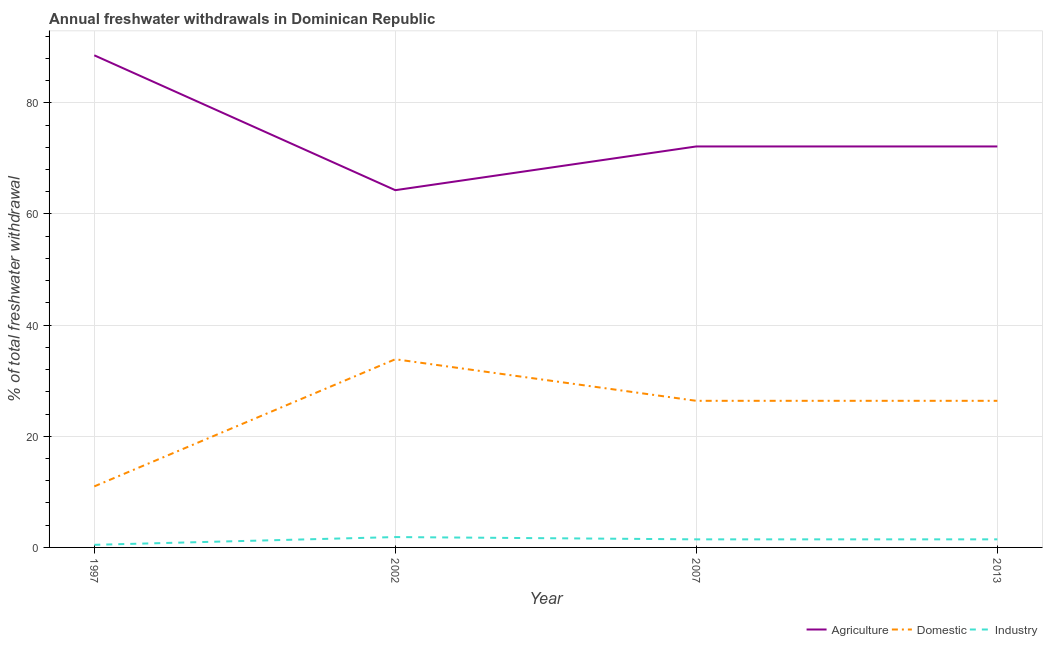How many different coloured lines are there?
Offer a very short reply. 3. Is the number of lines equal to the number of legend labels?
Give a very brief answer. Yes. What is the percentage of freshwater withdrawal for agriculture in 1997?
Your answer should be compact. 88.55. Across all years, what is the maximum percentage of freshwater withdrawal for industry?
Make the answer very short. 1.86. Across all years, what is the minimum percentage of freshwater withdrawal for industry?
Provide a short and direct response. 0.47. What is the total percentage of freshwater withdrawal for agriculture in the graph?
Offer a terse response. 297.13. What is the difference between the percentage of freshwater withdrawal for industry in 1997 and that in 2002?
Provide a short and direct response. -1.4. What is the difference between the percentage of freshwater withdrawal for industry in 1997 and the percentage of freshwater withdrawal for agriculture in 2002?
Provide a short and direct response. -63.81. What is the average percentage of freshwater withdrawal for domestic purposes per year?
Give a very brief answer. 24.4. In the year 2002, what is the difference between the percentage of freshwater withdrawal for industry and percentage of freshwater withdrawal for domestic purposes?
Make the answer very short. -32. What is the ratio of the percentage of freshwater withdrawal for industry in 1997 to that in 2007?
Offer a terse response. 0.32. Is the difference between the percentage of freshwater withdrawal for industry in 1997 and 2007 greater than the difference between the percentage of freshwater withdrawal for domestic purposes in 1997 and 2007?
Provide a succinct answer. Yes. What is the difference between the highest and the second highest percentage of freshwater withdrawal for industry?
Provide a succinct answer. 0.41. What is the difference between the highest and the lowest percentage of freshwater withdrawal for domestic purposes?
Your response must be concise. 22.88. Is it the case that in every year, the sum of the percentage of freshwater withdrawal for agriculture and percentage of freshwater withdrawal for domestic purposes is greater than the percentage of freshwater withdrawal for industry?
Give a very brief answer. Yes. Is the percentage of freshwater withdrawal for domestic purposes strictly less than the percentage of freshwater withdrawal for industry over the years?
Make the answer very short. No. How many lines are there?
Your answer should be compact. 3. How many years are there in the graph?
Your response must be concise. 4. Does the graph contain grids?
Provide a short and direct response. Yes. How many legend labels are there?
Give a very brief answer. 3. What is the title of the graph?
Your response must be concise. Annual freshwater withdrawals in Dominican Republic. What is the label or title of the Y-axis?
Your answer should be compact. % of total freshwater withdrawal. What is the % of total freshwater withdrawal of Agriculture in 1997?
Your answer should be compact. 88.55. What is the % of total freshwater withdrawal in Domestic in 1997?
Your answer should be very brief. 10.98. What is the % of total freshwater withdrawal of Industry in 1997?
Your answer should be compact. 0.47. What is the % of total freshwater withdrawal in Agriculture in 2002?
Provide a succinct answer. 64.28. What is the % of total freshwater withdrawal in Domestic in 2002?
Provide a short and direct response. 33.86. What is the % of total freshwater withdrawal in Industry in 2002?
Give a very brief answer. 1.86. What is the % of total freshwater withdrawal of Agriculture in 2007?
Offer a terse response. 72.15. What is the % of total freshwater withdrawal of Domestic in 2007?
Offer a terse response. 26.38. What is the % of total freshwater withdrawal of Industry in 2007?
Ensure brevity in your answer.  1.45. What is the % of total freshwater withdrawal in Agriculture in 2013?
Keep it short and to the point. 72.15. What is the % of total freshwater withdrawal of Domestic in 2013?
Offer a terse response. 26.38. What is the % of total freshwater withdrawal in Industry in 2013?
Provide a succinct answer. 1.45. Across all years, what is the maximum % of total freshwater withdrawal in Agriculture?
Ensure brevity in your answer.  88.55. Across all years, what is the maximum % of total freshwater withdrawal in Domestic?
Your answer should be very brief. 33.86. Across all years, what is the maximum % of total freshwater withdrawal of Industry?
Provide a short and direct response. 1.86. Across all years, what is the minimum % of total freshwater withdrawal of Agriculture?
Your answer should be compact. 64.28. Across all years, what is the minimum % of total freshwater withdrawal of Domestic?
Offer a very short reply. 10.98. Across all years, what is the minimum % of total freshwater withdrawal in Industry?
Offer a very short reply. 0.47. What is the total % of total freshwater withdrawal in Agriculture in the graph?
Your response must be concise. 297.13. What is the total % of total freshwater withdrawal of Domestic in the graph?
Your answer should be compact. 97.6. What is the total % of total freshwater withdrawal of Industry in the graph?
Offer a terse response. 5.24. What is the difference between the % of total freshwater withdrawal of Agriculture in 1997 and that in 2002?
Ensure brevity in your answer.  24.27. What is the difference between the % of total freshwater withdrawal in Domestic in 1997 and that in 2002?
Your response must be concise. -22.88. What is the difference between the % of total freshwater withdrawal in Industry in 1997 and that in 2002?
Provide a succinct answer. -1.4. What is the difference between the % of total freshwater withdrawal of Domestic in 1997 and that in 2007?
Your answer should be very brief. -15.4. What is the difference between the % of total freshwater withdrawal of Industry in 1997 and that in 2007?
Ensure brevity in your answer.  -0.99. What is the difference between the % of total freshwater withdrawal of Agriculture in 1997 and that in 2013?
Your answer should be compact. 16.4. What is the difference between the % of total freshwater withdrawal in Domestic in 1997 and that in 2013?
Give a very brief answer. -15.4. What is the difference between the % of total freshwater withdrawal in Industry in 1997 and that in 2013?
Keep it short and to the point. -0.99. What is the difference between the % of total freshwater withdrawal in Agriculture in 2002 and that in 2007?
Your answer should be very brief. -7.87. What is the difference between the % of total freshwater withdrawal in Domestic in 2002 and that in 2007?
Provide a short and direct response. 7.48. What is the difference between the % of total freshwater withdrawal of Industry in 2002 and that in 2007?
Make the answer very short. 0.41. What is the difference between the % of total freshwater withdrawal of Agriculture in 2002 and that in 2013?
Ensure brevity in your answer.  -7.87. What is the difference between the % of total freshwater withdrawal of Domestic in 2002 and that in 2013?
Your answer should be very brief. 7.48. What is the difference between the % of total freshwater withdrawal in Industry in 2002 and that in 2013?
Give a very brief answer. 0.41. What is the difference between the % of total freshwater withdrawal in Agriculture in 1997 and the % of total freshwater withdrawal in Domestic in 2002?
Provide a succinct answer. 54.69. What is the difference between the % of total freshwater withdrawal of Agriculture in 1997 and the % of total freshwater withdrawal of Industry in 2002?
Your response must be concise. 86.69. What is the difference between the % of total freshwater withdrawal of Domestic in 1997 and the % of total freshwater withdrawal of Industry in 2002?
Offer a terse response. 9.12. What is the difference between the % of total freshwater withdrawal of Agriculture in 1997 and the % of total freshwater withdrawal of Domestic in 2007?
Give a very brief answer. 62.17. What is the difference between the % of total freshwater withdrawal in Agriculture in 1997 and the % of total freshwater withdrawal in Industry in 2007?
Provide a succinct answer. 87.1. What is the difference between the % of total freshwater withdrawal in Domestic in 1997 and the % of total freshwater withdrawal in Industry in 2007?
Offer a terse response. 9.53. What is the difference between the % of total freshwater withdrawal in Agriculture in 1997 and the % of total freshwater withdrawal in Domestic in 2013?
Ensure brevity in your answer.  62.17. What is the difference between the % of total freshwater withdrawal of Agriculture in 1997 and the % of total freshwater withdrawal of Industry in 2013?
Provide a short and direct response. 87.1. What is the difference between the % of total freshwater withdrawal of Domestic in 1997 and the % of total freshwater withdrawal of Industry in 2013?
Your answer should be very brief. 9.53. What is the difference between the % of total freshwater withdrawal of Agriculture in 2002 and the % of total freshwater withdrawal of Domestic in 2007?
Provide a succinct answer. 37.9. What is the difference between the % of total freshwater withdrawal of Agriculture in 2002 and the % of total freshwater withdrawal of Industry in 2007?
Provide a succinct answer. 62.83. What is the difference between the % of total freshwater withdrawal of Domestic in 2002 and the % of total freshwater withdrawal of Industry in 2007?
Provide a succinct answer. 32.41. What is the difference between the % of total freshwater withdrawal of Agriculture in 2002 and the % of total freshwater withdrawal of Domestic in 2013?
Your answer should be compact. 37.9. What is the difference between the % of total freshwater withdrawal of Agriculture in 2002 and the % of total freshwater withdrawal of Industry in 2013?
Give a very brief answer. 62.83. What is the difference between the % of total freshwater withdrawal in Domestic in 2002 and the % of total freshwater withdrawal in Industry in 2013?
Give a very brief answer. 32.41. What is the difference between the % of total freshwater withdrawal in Agriculture in 2007 and the % of total freshwater withdrawal in Domestic in 2013?
Your answer should be compact. 45.77. What is the difference between the % of total freshwater withdrawal in Agriculture in 2007 and the % of total freshwater withdrawal in Industry in 2013?
Provide a short and direct response. 70.7. What is the difference between the % of total freshwater withdrawal of Domestic in 2007 and the % of total freshwater withdrawal of Industry in 2013?
Give a very brief answer. 24.93. What is the average % of total freshwater withdrawal in Agriculture per year?
Give a very brief answer. 74.28. What is the average % of total freshwater withdrawal of Domestic per year?
Keep it short and to the point. 24.4. What is the average % of total freshwater withdrawal in Industry per year?
Provide a succinct answer. 1.31. In the year 1997, what is the difference between the % of total freshwater withdrawal in Agriculture and % of total freshwater withdrawal in Domestic?
Give a very brief answer. 77.57. In the year 1997, what is the difference between the % of total freshwater withdrawal of Agriculture and % of total freshwater withdrawal of Industry?
Offer a very short reply. 88.08. In the year 1997, what is the difference between the % of total freshwater withdrawal of Domestic and % of total freshwater withdrawal of Industry?
Ensure brevity in your answer.  10.51. In the year 2002, what is the difference between the % of total freshwater withdrawal in Agriculture and % of total freshwater withdrawal in Domestic?
Ensure brevity in your answer.  30.42. In the year 2002, what is the difference between the % of total freshwater withdrawal in Agriculture and % of total freshwater withdrawal in Industry?
Your answer should be very brief. 62.41. In the year 2002, what is the difference between the % of total freshwater withdrawal in Domestic and % of total freshwater withdrawal in Industry?
Your answer should be very brief. 32. In the year 2007, what is the difference between the % of total freshwater withdrawal in Agriculture and % of total freshwater withdrawal in Domestic?
Keep it short and to the point. 45.77. In the year 2007, what is the difference between the % of total freshwater withdrawal in Agriculture and % of total freshwater withdrawal in Industry?
Give a very brief answer. 70.7. In the year 2007, what is the difference between the % of total freshwater withdrawal of Domestic and % of total freshwater withdrawal of Industry?
Give a very brief answer. 24.93. In the year 2013, what is the difference between the % of total freshwater withdrawal of Agriculture and % of total freshwater withdrawal of Domestic?
Your answer should be very brief. 45.77. In the year 2013, what is the difference between the % of total freshwater withdrawal in Agriculture and % of total freshwater withdrawal in Industry?
Give a very brief answer. 70.7. In the year 2013, what is the difference between the % of total freshwater withdrawal of Domestic and % of total freshwater withdrawal of Industry?
Keep it short and to the point. 24.93. What is the ratio of the % of total freshwater withdrawal in Agriculture in 1997 to that in 2002?
Ensure brevity in your answer.  1.38. What is the ratio of the % of total freshwater withdrawal in Domestic in 1997 to that in 2002?
Your response must be concise. 0.32. What is the ratio of the % of total freshwater withdrawal in Industry in 1997 to that in 2002?
Your answer should be compact. 0.25. What is the ratio of the % of total freshwater withdrawal of Agriculture in 1997 to that in 2007?
Provide a succinct answer. 1.23. What is the ratio of the % of total freshwater withdrawal in Domestic in 1997 to that in 2007?
Offer a very short reply. 0.42. What is the ratio of the % of total freshwater withdrawal of Industry in 1997 to that in 2007?
Your answer should be very brief. 0.32. What is the ratio of the % of total freshwater withdrawal in Agriculture in 1997 to that in 2013?
Keep it short and to the point. 1.23. What is the ratio of the % of total freshwater withdrawal in Domestic in 1997 to that in 2013?
Offer a very short reply. 0.42. What is the ratio of the % of total freshwater withdrawal in Industry in 1997 to that in 2013?
Offer a very short reply. 0.32. What is the ratio of the % of total freshwater withdrawal of Agriculture in 2002 to that in 2007?
Your answer should be very brief. 0.89. What is the ratio of the % of total freshwater withdrawal of Domestic in 2002 to that in 2007?
Give a very brief answer. 1.28. What is the ratio of the % of total freshwater withdrawal of Industry in 2002 to that in 2007?
Provide a succinct answer. 1.28. What is the ratio of the % of total freshwater withdrawal in Agriculture in 2002 to that in 2013?
Your answer should be very brief. 0.89. What is the ratio of the % of total freshwater withdrawal of Domestic in 2002 to that in 2013?
Provide a short and direct response. 1.28. What is the ratio of the % of total freshwater withdrawal in Industry in 2002 to that in 2013?
Make the answer very short. 1.28. What is the ratio of the % of total freshwater withdrawal in Agriculture in 2007 to that in 2013?
Your answer should be very brief. 1. What is the ratio of the % of total freshwater withdrawal in Domestic in 2007 to that in 2013?
Your response must be concise. 1. What is the ratio of the % of total freshwater withdrawal of Industry in 2007 to that in 2013?
Your answer should be compact. 1. What is the difference between the highest and the second highest % of total freshwater withdrawal in Agriculture?
Provide a short and direct response. 16.4. What is the difference between the highest and the second highest % of total freshwater withdrawal of Domestic?
Ensure brevity in your answer.  7.48. What is the difference between the highest and the second highest % of total freshwater withdrawal in Industry?
Give a very brief answer. 0.41. What is the difference between the highest and the lowest % of total freshwater withdrawal of Agriculture?
Give a very brief answer. 24.27. What is the difference between the highest and the lowest % of total freshwater withdrawal in Domestic?
Your answer should be compact. 22.88. What is the difference between the highest and the lowest % of total freshwater withdrawal of Industry?
Your answer should be very brief. 1.4. 